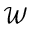<formula> <loc_0><loc_0><loc_500><loc_500>\mathcal { W }</formula> 